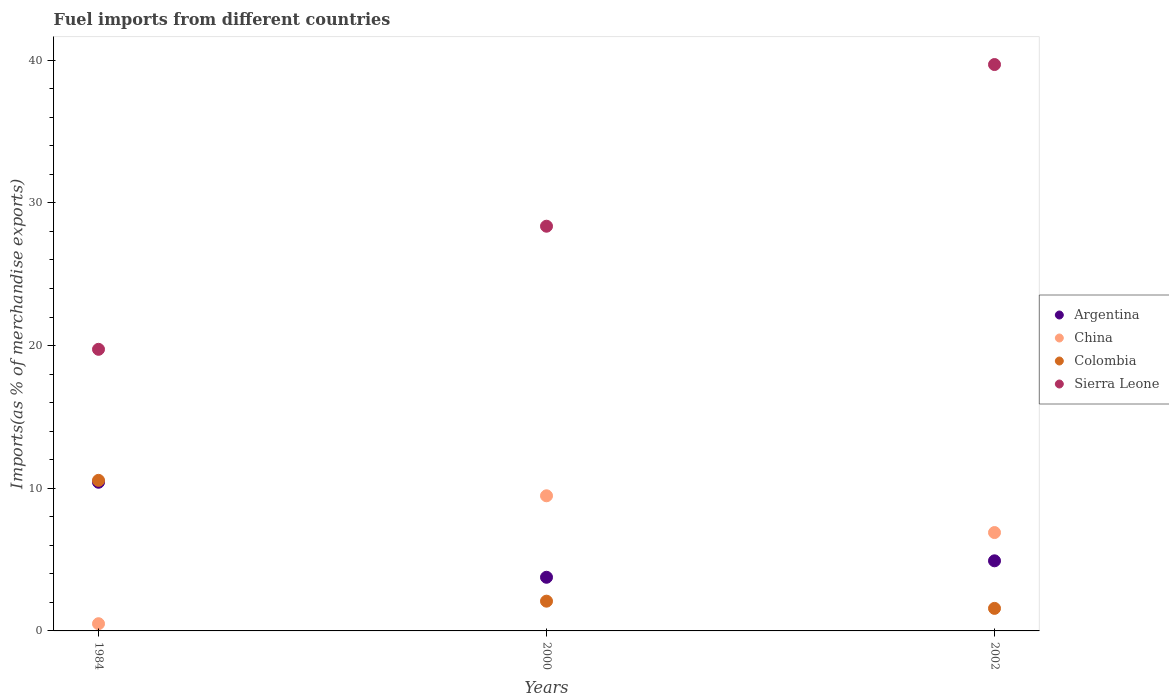How many different coloured dotlines are there?
Your answer should be very brief. 4. Is the number of dotlines equal to the number of legend labels?
Provide a succinct answer. Yes. What is the percentage of imports to different countries in China in 2000?
Provide a short and direct response. 9.47. Across all years, what is the maximum percentage of imports to different countries in China?
Offer a terse response. 9.47. Across all years, what is the minimum percentage of imports to different countries in Colombia?
Your answer should be compact. 1.58. In which year was the percentage of imports to different countries in China minimum?
Make the answer very short. 1984. What is the total percentage of imports to different countries in China in the graph?
Provide a short and direct response. 16.87. What is the difference between the percentage of imports to different countries in Sierra Leone in 1984 and that in 2000?
Offer a terse response. -8.63. What is the difference between the percentage of imports to different countries in China in 2002 and the percentage of imports to different countries in Argentina in 2000?
Offer a very short reply. 3.13. What is the average percentage of imports to different countries in Argentina per year?
Provide a short and direct response. 6.37. In the year 2000, what is the difference between the percentage of imports to different countries in Sierra Leone and percentage of imports to different countries in Colombia?
Provide a succinct answer. 26.28. In how many years, is the percentage of imports to different countries in China greater than 20 %?
Keep it short and to the point. 0. What is the ratio of the percentage of imports to different countries in Colombia in 2000 to that in 2002?
Keep it short and to the point. 1.32. Is the difference between the percentage of imports to different countries in Sierra Leone in 2000 and 2002 greater than the difference between the percentage of imports to different countries in Colombia in 2000 and 2002?
Keep it short and to the point. No. What is the difference between the highest and the second highest percentage of imports to different countries in Argentina?
Give a very brief answer. 5.51. What is the difference between the highest and the lowest percentage of imports to different countries in Colombia?
Make the answer very short. 8.97. In how many years, is the percentage of imports to different countries in Sierra Leone greater than the average percentage of imports to different countries in Sierra Leone taken over all years?
Provide a short and direct response. 1. Is the sum of the percentage of imports to different countries in China in 1984 and 2002 greater than the maximum percentage of imports to different countries in Sierra Leone across all years?
Offer a terse response. No. Is it the case that in every year, the sum of the percentage of imports to different countries in China and percentage of imports to different countries in Sierra Leone  is greater than the sum of percentage of imports to different countries in Colombia and percentage of imports to different countries in Argentina?
Give a very brief answer. Yes. Does the percentage of imports to different countries in China monotonically increase over the years?
Offer a very short reply. No. Is the percentage of imports to different countries in Sierra Leone strictly less than the percentage of imports to different countries in China over the years?
Offer a very short reply. No. How many dotlines are there?
Offer a very short reply. 4. How many years are there in the graph?
Keep it short and to the point. 3. What is the difference between two consecutive major ticks on the Y-axis?
Give a very brief answer. 10. Does the graph contain any zero values?
Offer a terse response. No. How many legend labels are there?
Give a very brief answer. 4. How are the legend labels stacked?
Offer a terse response. Vertical. What is the title of the graph?
Keep it short and to the point. Fuel imports from different countries. What is the label or title of the Y-axis?
Your response must be concise. Imports(as % of merchandise exports). What is the Imports(as % of merchandise exports) in Argentina in 1984?
Provide a succinct answer. 10.42. What is the Imports(as % of merchandise exports) of China in 1984?
Your answer should be compact. 0.51. What is the Imports(as % of merchandise exports) in Colombia in 1984?
Offer a very short reply. 10.55. What is the Imports(as % of merchandise exports) in Sierra Leone in 1984?
Offer a terse response. 19.74. What is the Imports(as % of merchandise exports) in Argentina in 2000?
Keep it short and to the point. 3.76. What is the Imports(as % of merchandise exports) in China in 2000?
Provide a succinct answer. 9.47. What is the Imports(as % of merchandise exports) in Colombia in 2000?
Your answer should be compact. 2.09. What is the Imports(as % of merchandise exports) in Sierra Leone in 2000?
Provide a short and direct response. 28.37. What is the Imports(as % of merchandise exports) of Argentina in 2002?
Make the answer very short. 4.91. What is the Imports(as % of merchandise exports) in China in 2002?
Your response must be concise. 6.89. What is the Imports(as % of merchandise exports) of Colombia in 2002?
Ensure brevity in your answer.  1.58. What is the Imports(as % of merchandise exports) of Sierra Leone in 2002?
Offer a very short reply. 39.7. Across all years, what is the maximum Imports(as % of merchandise exports) in Argentina?
Give a very brief answer. 10.42. Across all years, what is the maximum Imports(as % of merchandise exports) in China?
Your response must be concise. 9.47. Across all years, what is the maximum Imports(as % of merchandise exports) in Colombia?
Your response must be concise. 10.55. Across all years, what is the maximum Imports(as % of merchandise exports) in Sierra Leone?
Provide a short and direct response. 39.7. Across all years, what is the minimum Imports(as % of merchandise exports) of Argentina?
Offer a very short reply. 3.76. Across all years, what is the minimum Imports(as % of merchandise exports) of China?
Your answer should be very brief. 0.51. Across all years, what is the minimum Imports(as % of merchandise exports) of Colombia?
Your response must be concise. 1.58. Across all years, what is the minimum Imports(as % of merchandise exports) in Sierra Leone?
Provide a short and direct response. 19.74. What is the total Imports(as % of merchandise exports) of Argentina in the graph?
Provide a short and direct response. 19.1. What is the total Imports(as % of merchandise exports) in China in the graph?
Make the answer very short. 16.87. What is the total Imports(as % of merchandise exports) in Colombia in the graph?
Make the answer very short. 14.22. What is the total Imports(as % of merchandise exports) of Sierra Leone in the graph?
Keep it short and to the point. 87.8. What is the difference between the Imports(as % of merchandise exports) in Argentina in 1984 and that in 2000?
Ensure brevity in your answer.  6.66. What is the difference between the Imports(as % of merchandise exports) in China in 1984 and that in 2000?
Give a very brief answer. -8.97. What is the difference between the Imports(as % of merchandise exports) of Colombia in 1984 and that in 2000?
Provide a short and direct response. 8.47. What is the difference between the Imports(as % of merchandise exports) of Sierra Leone in 1984 and that in 2000?
Provide a short and direct response. -8.63. What is the difference between the Imports(as % of merchandise exports) in Argentina in 1984 and that in 2002?
Your answer should be very brief. 5.51. What is the difference between the Imports(as % of merchandise exports) of China in 1984 and that in 2002?
Your response must be concise. -6.39. What is the difference between the Imports(as % of merchandise exports) of Colombia in 1984 and that in 2002?
Keep it short and to the point. 8.97. What is the difference between the Imports(as % of merchandise exports) of Sierra Leone in 1984 and that in 2002?
Make the answer very short. -19.96. What is the difference between the Imports(as % of merchandise exports) of Argentina in 2000 and that in 2002?
Your response must be concise. -1.15. What is the difference between the Imports(as % of merchandise exports) of China in 2000 and that in 2002?
Make the answer very short. 2.58. What is the difference between the Imports(as % of merchandise exports) of Colombia in 2000 and that in 2002?
Make the answer very short. 0.51. What is the difference between the Imports(as % of merchandise exports) in Sierra Leone in 2000 and that in 2002?
Provide a succinct answer. -11.33. What is the difference between the Imports(as % of merchandise exports) of Argentina in 1984 and the Imports(as % of merchandise exports) of China in 2000?
Your response must be concise. 0.95. What is the difference between the Imports(as % of merchandise exports) of Argentina in 1984 and the Imports(as % of merchandise exports) of Colombia in 2000?
Your response must be concise. 8.34. What is the difference between the Imports(as % of merchandise exports) in Argentina in 1984 and the Imports(as % of merchandise exports) in Sierra Leone in 2000?
Offer a very short reply. -17.95. What is the difference between the Imports(as % of merchandise exports) of China in 1984 and the Imports(as % of merchandise exports) of Colombia in 2000?
Ensure brevity in your answer.  -1.58. What is the difference between the Imports(as % of merchandise exports) of China in 1984 and the Imports(as % of merchandise exports) of Sierra Leone in 2000?
Provide a succinct answer. -27.86. What is the difference between the Imports(as % of merchandise exports) of Colombia in 1984 and the Imports(as % of merchandise exports) of Sierra Leone in 2000?
Offer a very short reply. -17.81. What is the difference between the Imports(as % of merchandise exports) in Argentina in 1984 and the Imports(as % of merchandise exports) in China in 2002?
Give a very brief answer. 3.53. What is the difference between the Imports(as % of merchandise exports) in Argentina in 1984 and the Imports(as % of merchandise exports) in Colombia in 2002?
Your answer should be very brief. 8.84. What is the difference between the Imports(as % of merchandise exports) in Argentina in 1984 and the Imports(as % of merchandise exports) in Sierra Leone in 2002?
Offer a very short reply. -29.28. What is the difference between the Imports(as % of merchandise exports) in China in 1984 and the Imports(as % of merchandise exports) in Colombia in 2002?
Provide a succinct answer. -1.07. What is the difference between the Imports(as % of merchandise exports) of China in 1984 and the Imports(as % of merchandise exports) of Sierra Leone in 2002?
Offer a very short reply. -39.19. What is the difference between the Imports(as % of merchandise exports) of Colombia in 1984 and the Imports(as % of merchandise exports) of Sierra Leone in 2002?
Offer a terse response. -29.14. What is the difference between the Imports(as % of merchandise exports) of Argentina in 2000 and the Imports(as % of merchandise exports) of China in 2002?
Offer a terse response. -3.13. What is the difference between the Imports(as % of merchandise exports) in Argentina in 2000 and the Imports(as % of merchandise exports) in Colombia in 2002?
Ensure brevity in your answer.  2.18. What is the difference between the Imports(as % of merchandise exports) in Argentina in 2000 and the Imports(as % of merchandise exports) in Sierra Leone in 2002?
Your answer should be compact. -35.94. What is the difference between the Imports(as % of merchandise exports) of China in 2000 and the Imports(as % of merchandise exports) of Colombia in 2002?
Provide a short and direct response. 7.89. What is the difference between the Imports(as % of merchandise exports) in China in 2000 and the Imports(as % of merchandise exports) in Sierra Leone in 2002?
Offer a very short reply. -30.23. What is the difference between the Imports(as % of merchandise exports) in Colombia in 2000 and the Imports(as % of merchandise exports) in Sierra Leone in 2002?
Offer a very short reply. -37.61. What is the average Imports(as % of merchandise exports) of Argentina per year?
Make the answer very short. 6.37. What is the average Imports(as % of merchandise exports) in China per year?
Your response must be concise. 5.62. What is the average Imports(as % of merchandise exports) in Colombia per year?
Ensure brevity in your answer.  4.74. What is the average Imports(as % of merchandise exports) in Sierra Leone per year?
Your response must be concise. 29.27. In the year 1984, what is the difference between the Imports(as % of merchandise exports) in Argentina and Imports(as % of merchandise exports) in China?
Keep it short and to the point. 9.92. In the year 1984, what is the difference between the Imports(as % of merchandise exports) in Argentina and Imports(as % of merchandise exports) in Colombia?
Ensure brevity in your answer.  -0.13. In the year 1984, what is the difference between the Imports(as % of merchandise exports) in Argentina and Imports(as % of merchandise exports) in Sierra Leone?
Offer a very short reply. -9.32. In the year 1984, what is the difference between the Imports(as % of merchandise exports) of China and Imports(as % of merchandise exports) of Colombia?
Ensure brevity in your answer.  -10.05. In the year 1984, what is the difference between the Imports(as % of merchandise exports) of China and Imports(as % of merchandise exports) of Sierra Leone?
Provide a succinct answer. -19.23. In the year 1984, what is the difference between the Imports(as % of merchandise exports) of Colombia and Imports(as % of merchandise exports) of Sierra Leone?
Your answer should be very brief. -9.18. In the year 2000, what is the difference between the Imports(as % of merchandise exports) in Argentina and Imports(as % of merchandise exports) in China?
Keep it short and to the point. -5.71. In the year 2000, what is the difference between the Imports(as % of merchandise exports) of Argentina and Imports(as % of merchandise exports) of Colombia?
Give a very brief answer. 1.68. In the year 2000, what is the difference between the Imports(as % of merchandise exports) in Argentina and Imports(as % of merchandise exports) in Sierra Leone?
Keep it short and to the point. -24.61. In the year 2000, what is the difference between the Imports(as % of merchandise exports) in China and Imports(as % of merchandise exports) in Colombia?
Make the answer very short. 7.39. In the year 2000, what is the difference between the Imports(as % of merchandise exports) of China and Imports(as % of merchandise exports) of Sierra Leone?
Provide a succinct answer. -18.89. In the year 2000, what is the difference between the Imports(as % of merchandise exports) of Colombia and Imports(as % of merchandise exports) of Sierra Leone?
Your answer should be compact. -26.28. In the year 2002, what is the difference between the Imports(as % of merchandise exports) in Argentina and Imports(as % of merchandise exports) in China?
Make the answer very short. -1.98. In the year 2002, what is the difference between the Imports(as % of merchandise exports) of Argentina and Imports(as % of merchandise exports) of Colombia?
Provide a short and direct response. 3.33. In the year 2002, what is the difference between the Imports(as % of merchandise exports) of Argentina and Imports(as % of merchandise exports) of Sierra Leone?
Make the answer very short. -34.78. In the year 2002, what is the difference between the Imports(as % of merchandise exports) of China and Imports(as % of merchandise exports) of Colombia?
Ensure brevity in your answer.  5.31. In the year 2002, what is the difference between the Imports(as % of merchandise exports) in China and Imports(as % of merchandise exports) in Sierra Leone?
Ensure brevity in your answer.  -32.8. In the year 2002, what is the difference between the Imports(as % of merchandise exports) of Colombia and Imports(as % of merchandise exports) of Sierra Leone?
Make the answer very short. -38.12. What is the ratio of the Imports(as % of merchandise exports) of Argentina in 1984 to that in 2000?
Provide a short and direct response. 2.77. What is the ratio of the Imports(as % of merchandise exports) in China in 1984 to that in 2000?
Your response must be concise. 0.05. What is the ratio of the Imports(as % of merchandise exports) of Colombia in 1984 to that in 2000?
Make the answer very short. 5.06. What is the ratio of the Imports(as % of merchandise exports) in Sierra Leone in 1984 to that in 2000?
Give a very brief answer. 0.7. What is the ratio of the Imports(as % of merchandise exports) of Argentina in 1984 to that in 2002?
Make the answer very short. 2.12. What is the ratio of the Imports(as % of merchandise exports) of China in 1984 to that in 2002?
Your answer should be compact. 0.07. What is the ratio of the Imports(as % of merchandise exports) in Colombia in 1984 to that in 2002?
Provide a short and direct response. 6.68. What is the ratio of the Imports(as % of merchandise exports) of Sierra Leone in 1984 to that in 2002?
Your answer should be very brief. 0.5. What is the ratio of the Imports(as % of merchandise exports) of Argentina in 2000 to that in 2002?
Ensure brevity in your answer.  0.77. What is the ratio of the Imports(as % of merchandise exports) in China in 2000 to that in 2002?
Your response must be concise. 1.37. What is the ratio of the Imports(as % of merchandise exports) of Colombia in 2000 to that in 2002?
Provide a short and direct response. 1.32. What is the ratio of the Imports(as % of merchandise exports) of Sierra Leone in 2000 to that in 2002?
Ensure brevity in your answer.  0.71. What is the difference between the highest and the second highest Imports(as % of merchandise exports) in Argentina?
Your answer should be very brief. 5.51. What is the difference between the highest and the second highest Imports(as % of merchandise exports) in China?
Give a very brief answer. 2.58. What is the difference between the highest and the second highest Imports(as % of merchandise exports) in Colombia?
Offer a very short reply. 8.47. What is the difference between the highest and the second highest Imports(as % of merchandise exports) in Sierra Leone?
Your answer should be very brief. 11.33. What is the difference between the highest and the lowest Imports(as % of merchandise exports) in Argentina?
Ensure brevity in your answer.  6.66. What is the difference between the highest and the lowest Imports(as % of merchandise exports) of China?
Provide a succinct answer. 8.97. What is the difference between the highest and the lowest Imports(as % of merchandise exports) in Colombia?
Your answer should be very brief. 8.97. What is the difference between the highest and the lowest Imports(as % of merchandise exports) in Sierra Leone?
Your response must be concise. 19.96. 